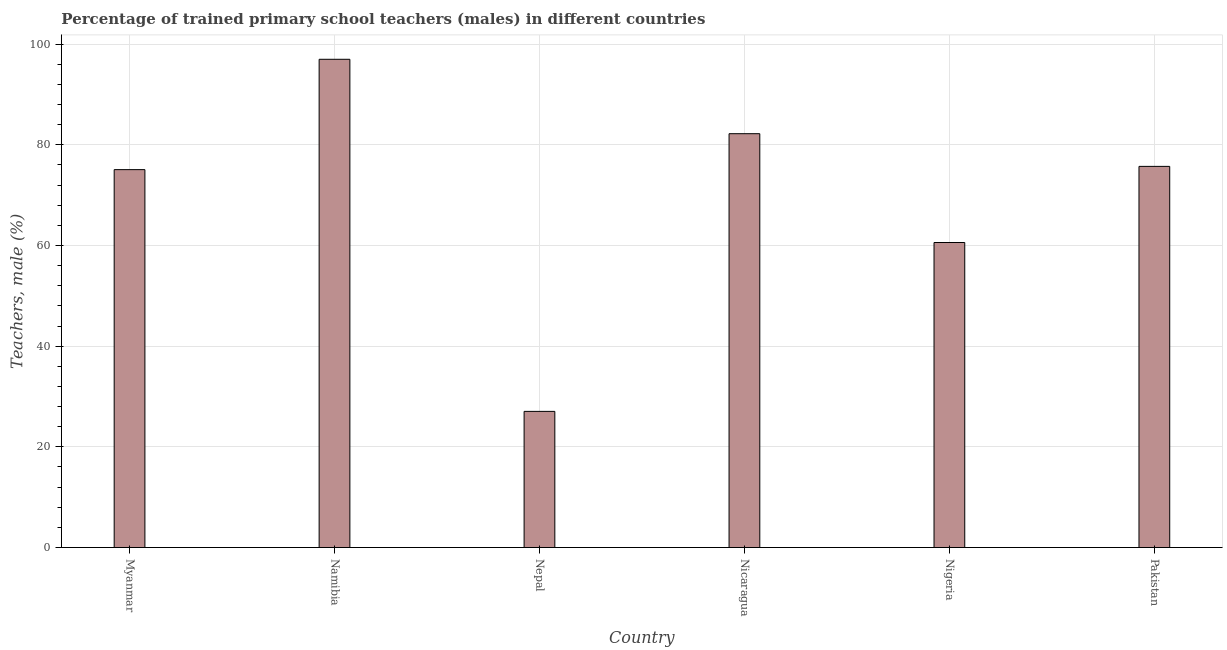Does the graph contain any zero values?
Your answer should be compact. No. Does the graph contain grids?
Provide a succinct answer. Yes. What is the title of the graph?
Provide a succinct answer. Percentage of trained primary school teachers (males) in different countries. What is the label or title of the X-axis?
Keep it short and to the point. Country. What is the label or title of the Y-axis?
Your answer should be compact. Teachers, male (%). What is the percentage of trained male teachers in Namibia?
Keep it short and to the point. 96.99. Across all countries, what is the maximum percentage of trained male teachers?
Provide a succinct answer. 96.99. Across all countries, what is the minimum percentage of trained male teachers?
Offer a terse response. 27.04. In which country was the percentage of trained male teachers maximum?
Make the answer very short. Namibia. In which country was the percentage of trained male teachers minimum?
Your answer should be very brief. Nepal. What is the sum of the percentage of trained male teachers?
Keep it short and to the point. 417.61. What is the difference between the percentage of trained male teachers in Namibia and Nicaragua?
Make the answer very short. 14.78. What is the average percentage of trained male teachers per country?
Ensure brevity in your answer.  69.6. What is the median percentage of trained male teachers?
Your response must be concise. 75.39. In how many countries, is the percentage of trained male teachers greater than 96 %?
Give a very brief answer. 1. What is the ratio of the percentage of trained male teachers in Myanmar to that in Pakistan?
Provide a short and direct response. 0.99. Is the percentage of trained male teachers in Nicaragua less than that in Nigeria?
Your response must be concise. No. Is the difference between the percentage of trained male teachers in Nepal and Nigeria greater than the difference between any two countries?
Your response must be concise. No. What is the difference between the highest and the second highest percentage of trained male teachers?
Give a very brief answer. 14.78. Is the sum of the percentage of trained male teachers in Nicaragua and Pakistan greater than the maximum percentage of trained male teachers across all countries?
Provide a short and direct response. Yes. What is the difference between the highest and the lowest percentage of trained male teachers?
Give a very brief answer. 69.94. How many bars are there?
Give a very brief answer. 6. Are all the bars in the graph horizontal?
Your answer should be very brief. No. What is the Teachers, male (%) of Myanmar?
Make the answer very short. 75.07. What is the Teachers, male (%) of Namibia?
Your response must be concise. 96.99. What is the Teachers, male (%) of Nepal?
Ensure brevity in your answer.  27.04. What is the Teachers, male (%) of Nicaragua?
Give a very brief answer. 82.21. What is the Teachers, male (%) of Nigeria?
Offer a very short reply. 60.59. What is the Teachers, male (%) of Pakistan?
Provide a short and direct response. 75.71. What is the difference between the Teachers, male (%) in Myanmar and Namibia?
Provide a succinct answer. -21.92. What is the difference between the Teachers, male (%) in Myanmar and Nepal?
Provide a succinct answer. 48.02. What is the difference between the Teachers, male (%) in Myanmar and Nicaragua?
Provide a succinct answer. -7.14. What is the difference between the Teachers, male (%) in Myanmar and Nigeria?
Keep it short and to the point. 14.48. What is the difference between the Teachers, male (%) in Myanmar and Pakistan?
Ensure brevity in your answer.  -0.65. What is the difference between the Teachers, male (%) in Namibia and Nepal?
Keep it short and to the point. 69.94. What is the difference between the Teachers, male (%) in Namibia and Nicaragua?
Offer a very short reply. 14.78. What is the difference between the Teachers, male (%) in Namibia and Nigeria?
Keep it short and to the point. 36.4. What is the difference between the Teachers, male (%) in Namibia and Pakistan?
Offer a very short reply. 21.28. What is the difference between the Teachers, male (%) in Nepal and Nicaragua?
Keep it short and to the point. -55.16. What is the difference between the Teachers, male (%) in Nepal and Nigeria?
Provide a succinct answer. -33.55. What is the difference between the Teachers, male (%) in Nepal and Pakistan?
Offer a terse response. -48.67. What is the difference between the Teachers, male (%) in Nicaragua and Nigeria?
Ensure brevity in your answer.  21.62. What is the difference between the Teachers, male (%) in Nicaragua and Pakistan?
Provide a succinct answer. 6.49. What is the difference between the Teachers, male (%) in Nigeria and Pakistan?
Give a very brief answer. -15.12. What is the ratio of the Teachers, male (%) in Myanmar to that in Namibia?
Ensure brevity in your answer.  0.77. What is the ratio of the Teachers, male (%) in Myanmar to that in Nepal?
Offer a very short reply. 2.78. What is the ratio of the Teachers, male (%) in Myanmar to that in Nigeria?
Ensure brevity in your answer.  1.24. What is the ratio of the Teachers, male (%) in Namibia to that in Nepal?
Provide a short and direct response. 3.59. What is the ratio of the Teachers, male (%) in Namibia to that in Nicaragua?
Offer a terse response. 1.18. What is the ratio of the Teachers, male (%) in Namibia to that in Nigeria?
Your answer should be very brief. 1.6. What is the ratio of the Teachers, male (%) in Namibia to that in Pakistan?
Provide a short and direct response. 1.28. What is the ratio of the Teachers, male (%) in Nepal to that in Nicaragua?
Provide a short and direct response. 0.33. What is the ratio of the Teachers, male (%) in Nepal to that in Nigeria?
Provide a short and direct response. 0.45. What is the ratio of the Teachers, male (%) in Nepal to that in Pakistan?
Your response must be concise. 0.36. What is the ratio of the Teachers, male (%) in Nicaragua to that in Nigeria?
Ensure brevity in your answer.  1.36. What is the ratio of the Teachers, male (%) in Nicaragua to that in Pakistan?
Keep it short and to the point. 1.09. 